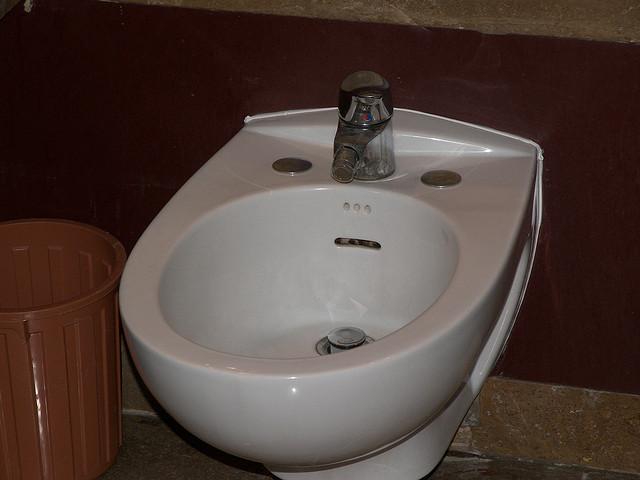What is this?
Keep it brief. Bidet. Do you see any place to throw trash?
Write a very short answer. Yes. Is this sink open or closed?
Short answer required. Open. 